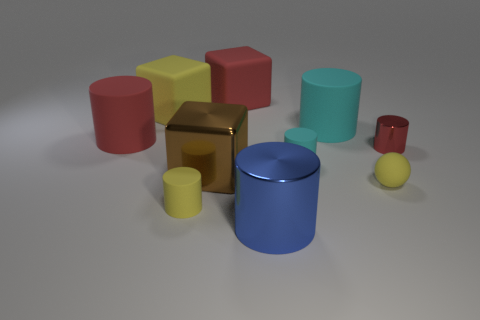Can you tell me about the materials and textures visible in the image? Certainly! In the image, we see a variety of objects with different textures and materials. The large red matte cylinder, a yellow matte cube, and a green matte cylinder have a non-reflective surface which suggests a matte texture. In contrast, the gold cube in the center shows a reflective surface indicating a metallic texture. Then there's a small shiny sphere and a shiny blue cylinder that appear to be glossy, likely made of plastic or a polished material. 